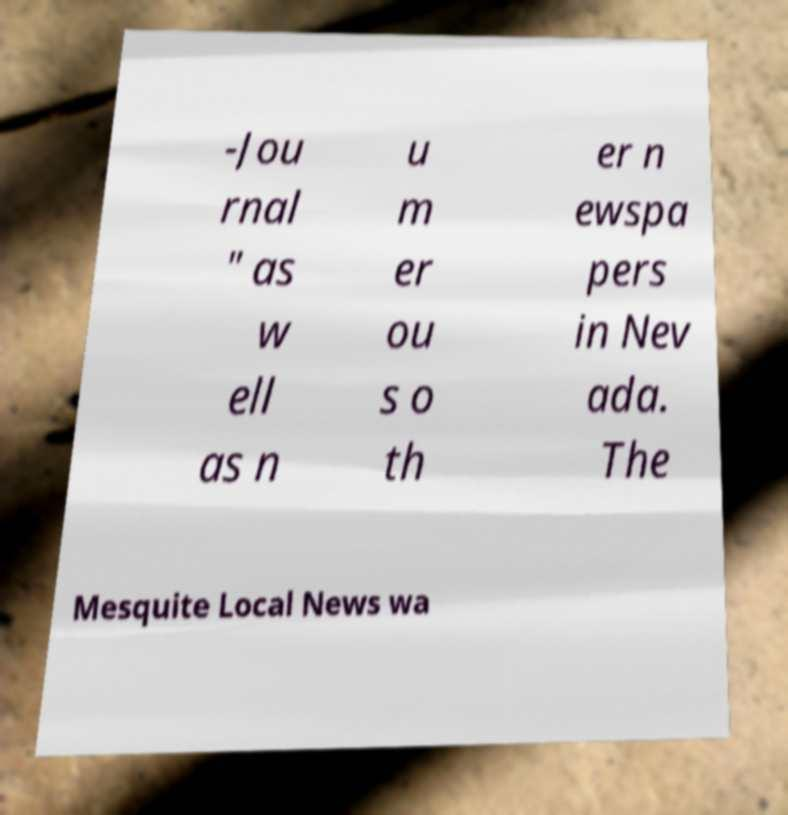Can you read and provide the text displayed in the image?This photo seems to have some interesting text. Can you extract and type it out for me? -Jou rnal " as w ell as n u m er ou s o th er n ewspa pers in Nev ada. The Mesquite Local News wa 